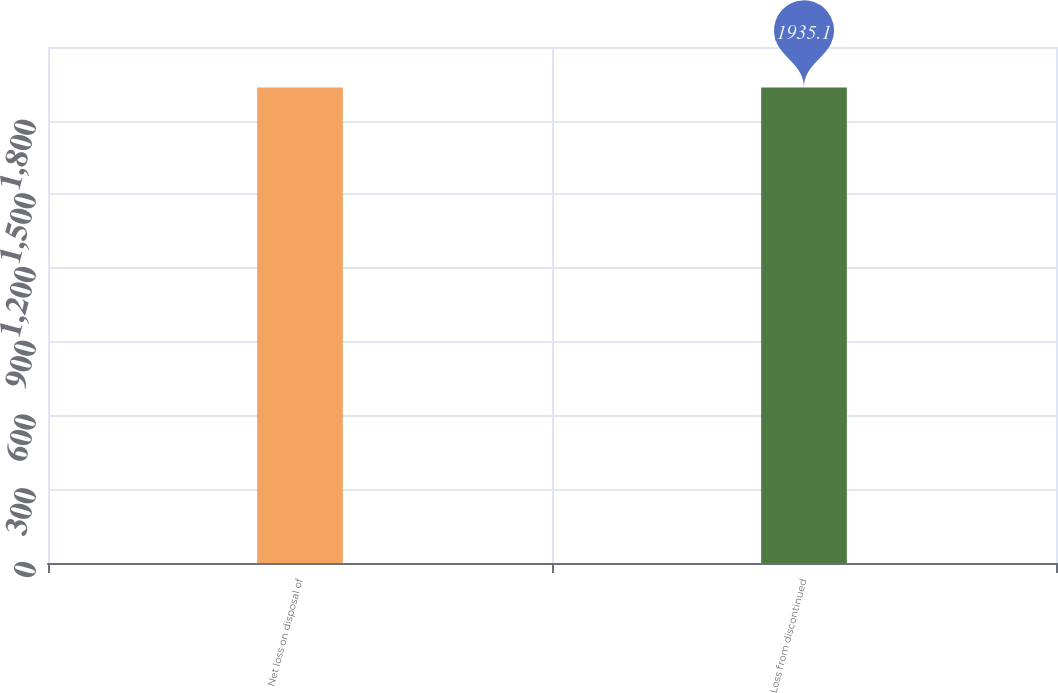Convert chart to OTSL. <chart><loc_0><loc_0><loc_500><loc_500><bar_chart><fcel>Net loss on disposal of<fcel>Loss from discontinued<nl><fcel>1935<fcel>1935.1<nl></chart> 